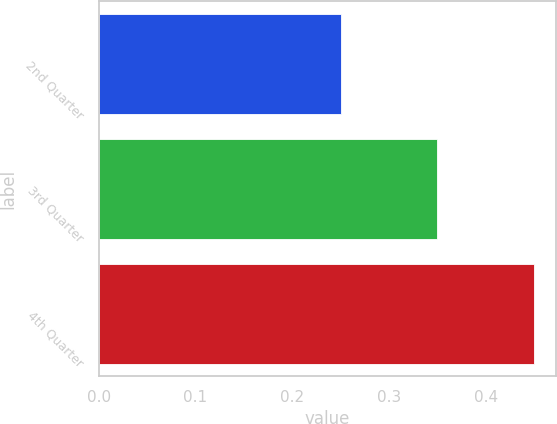Convert chart to OTSL. <chart><loc_0><loc_0><loc_500><loc_500><bar_chart><fcel>2nd Quarter<fcel>3rd Quarter<fcel>4th Quarter<nl><fcel>0.25<fcel>0.35<fcel>0.45<nl></chart> 